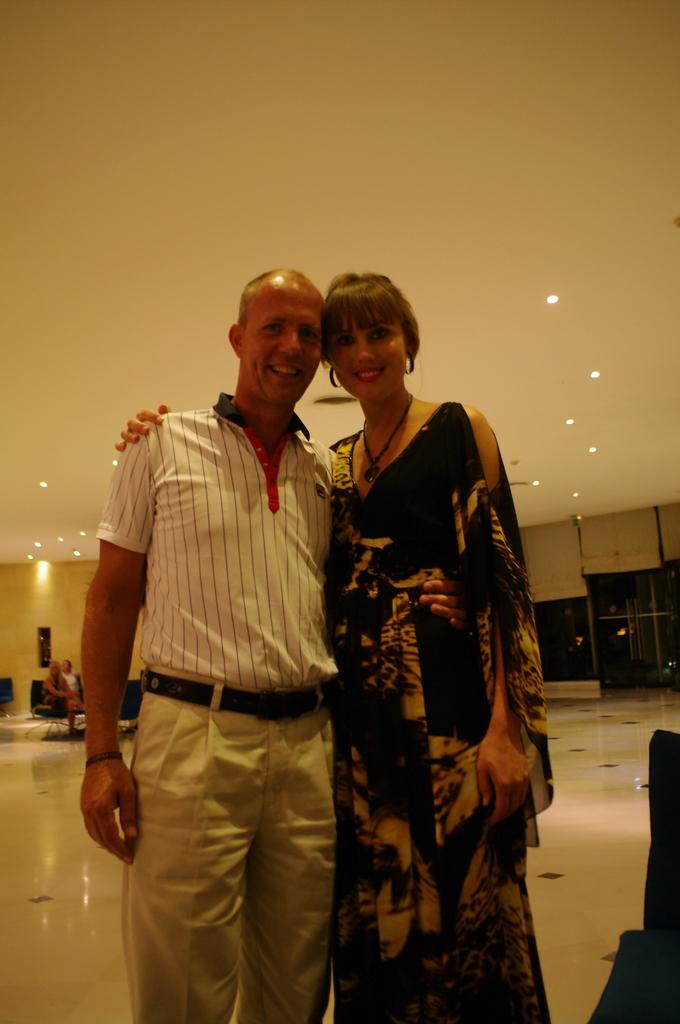Who is present in the image? There is a man and a woman in the image. What are the expressions on their faces? Both the man and the woman are smiling in the image. What can be seen on the ceiling in the image? There are lights on the ceiling in the image. What are the people in the image doing? There are people sitting in chairs in the image. What type of bone is visible on the man's hand in the image? There is no bone visible on the man's hand in the image. How many rings can be seen on the woman's fingers in the image? There are no rings visible on the woman's fingers in the image. 